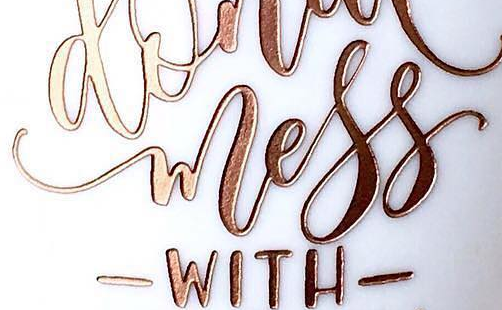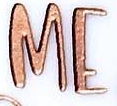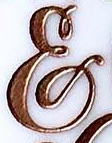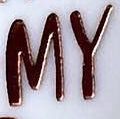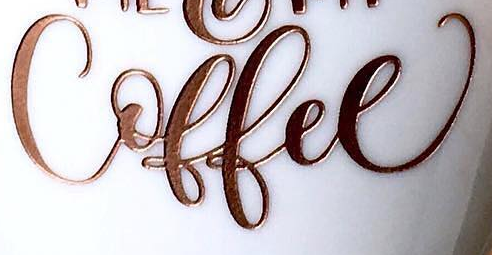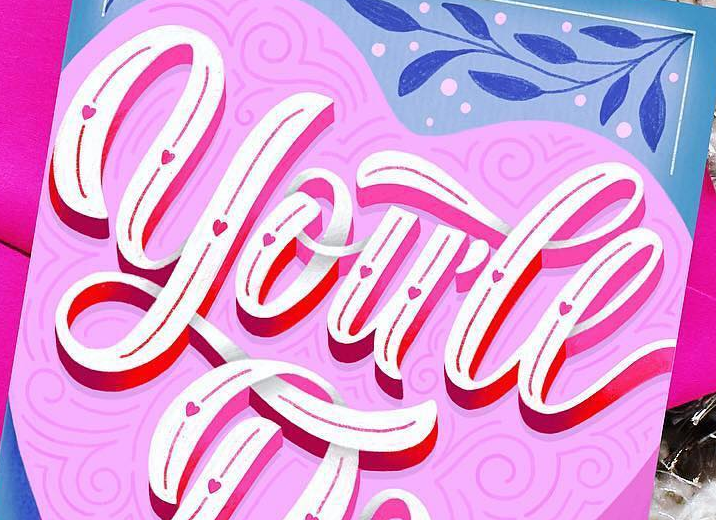Identify the words shown in these images in order, separated by a semicolon. wless; ME; &; MY; Coffee; you'll 